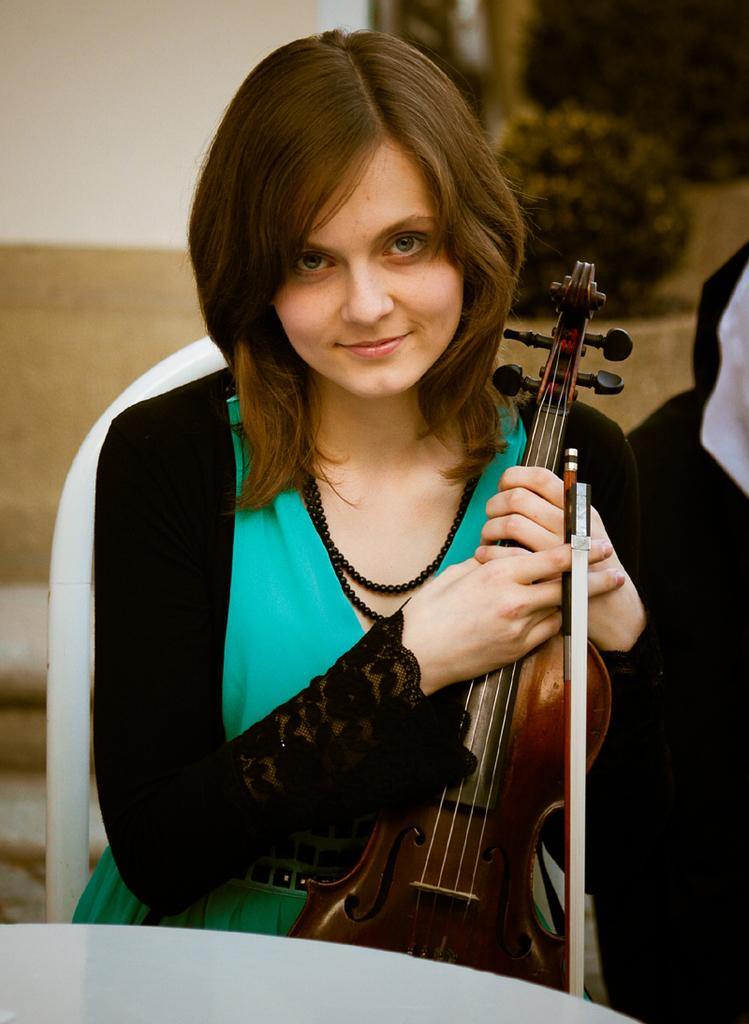What is the main subject of the image? There is a person in the image. What is the person doing in the image? The person is smiling and holding a musical instrument. What can be seen in the background of the image? There are trees in the background of the image. How much profit did the group make from the musical performance in the image? There is no information about a group or a musical performance in the image, so it is impossible to determine any profit made. 